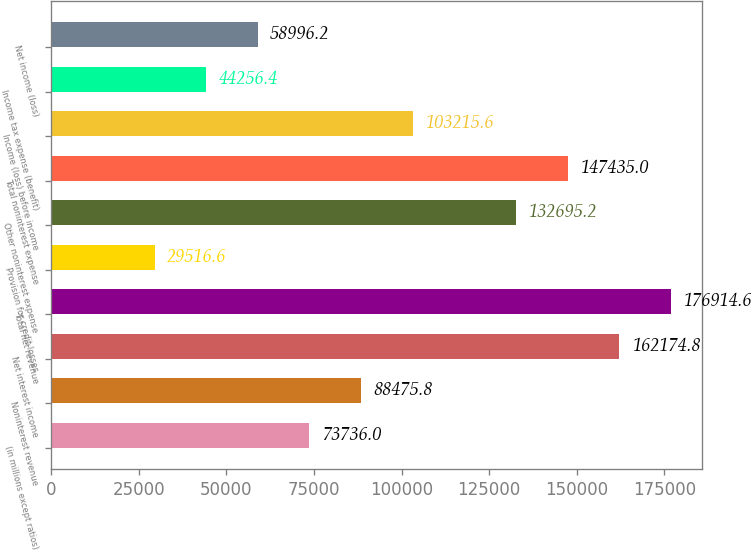Convert chart. <chart><loc_0><loc_0><loc_500><loc_500><bar_chart><fcel>(in millions except ratios)<fcel>Noninterest revenue<fcel>Net interest income<fcel>Total net revenue<fcel>Provision for credit losses<fcel>Other noninterest expense<fcel>Total noninterest expense<fcel>Income (loss) before income<fcel>Income tax expense (benefit)<fcel>Net income (loss)<nl><fcel>73736<fcel>88475.8<fcel>162175<fcel>176915<fcel>29516.6<fcel>132695<fcel>147435<fcel>103216<fcel>44256.4<fcel>58996.2<nl></chart> 